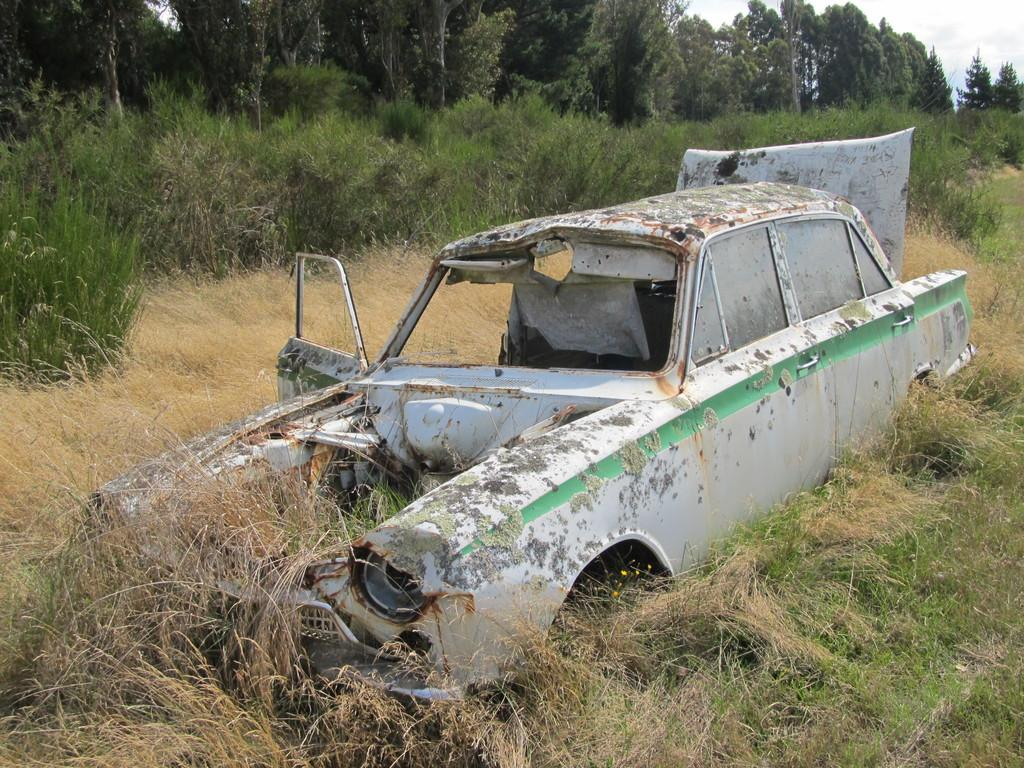What is the condition of the vehicle in the image? The vehicle in the image is damaged. What type of vegetation is at the bottom of the image? There is grass at the bottom of the image. What can be seen in the background of the image? There are trees and plants in the background of the image. What type of invention is being demonstrated by the children in the image? There are no children or inventions present in the image. 